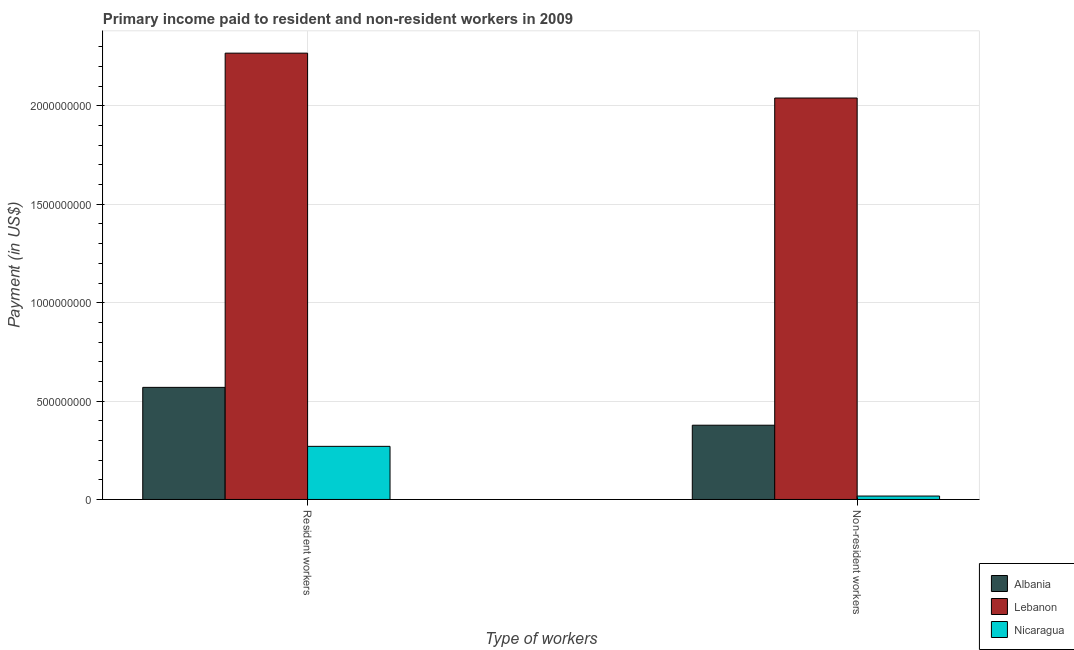How many groups of bars are there?
Give a very brief answer. 2. Are the number of bars on each tick of the X-axis equal?
Your answer should be compact. Yes. How many bars are there on the 2nd tick from the right?
Make the answer very short. 3. What is the label of the 1st group of bars from the left?
Your response must be concise. Resident workers. What is the payment made to resident workers in Albania?
Keep it short and to the point. 5.70e+08. Across all countries, what is the maximum payment made to resident workers?
Your answer should be very brief. 2.27e+09. Across all countries, what is the minimum payment made to resident workers?
Your response must be concise. 2.70e+08. In which country was the payment made to non-resident workers maximum?
Your response must be concise. Lebanon. In which country was the payment made to resident workers minimum?
Offer a very short reply. Nicaragua. What is the total payment made to resident workers in the graph?
Provide a succinct answer. 3.11e+09. What is the difference between the payment made to non-resident workers in Lebanon and that in Nicaragua?
Offer a terse response. 2.02e+09. What is the difference between the payment made to resident workers in Lebanon and the payment made to non-resident workers in Nicaragua?
Provide a short and direct response. 2.25e+09. What is the average payment made to resident workers per country?
Your answer should be very brief. 1.04e+09. What is the difference between the payment made to non-resident workers and payment made to resident workers in Albania?
Offer a very short reply. -1.92e+08. What is the ratio of the payment made to resident workers in Nicaragua to that in Albania?
Ensure brevity in your answer.  0.47. Is the payment made to non-resident workers in Nicaragua less than that in Albania?
Ensure brevity in your answer.  Yes. What does the 1st bar from the left in Non-resident workers represents?
Offer a terse response. Albania. What does the 3rd bar from the right in Non-resident workers represents?
Ensure brevity in your answer.  Albania. How many bars are there?
Offer a very short reply. 6. Are all the bars in the graph horizontal?
Give a very brief answer. No. What is the difference between two consecutive major ticks on the Y-axis?
Offer a terse response. 5.00e+08. Are the values on the major ticks of Y-axis written in scientific E-notation?
Ensure brevity in your answer.  No. Does the graph contain any zero values?
Offer a very short reply. No. How many legend labels are there?
Your answer should be compact. 3. What is the title of the graph?
Provide a succinct answer. Primary income paid to resident and non-resident workers in 2009. Does "Maldives" appear as one of the legend labels in the graph?
Your answer should be compact. No. What is the label or title of the X-axis?
Ensure brevity in your answer.  Type of workers. What is the label or title of the Y-axis?
Your response must be concise. Payment (in US$). What is the Payment (in US$) of Albania in Resident workers?
Provide a short and direct response. 5.70e+08. What is the Payment (in US$) in Lebanon in Resident workers?
Offer a very short reply. 2.27e+09. What is the Payment (in US$) of Nicaragua in Resident workers?
Offer a terse response. 2.70e+08. What is the Payment (in US$) of Albania in Non-resident workers?
Offer a terse response. 3.77e+08. What is the Payment (in US$) of Lebanon in Non-resident workers?
Offer a very short reply. 2.04e+09. What is the Payment (in US$) in Nicaragua in Non-resident workers?
Provide a short and direct response. 1.73e+07. Across all Type of workers, what is the maximum Payment (in US$) in Albania?
Provide a succinct answer. 5.70e+08. Across all Type of workers, what is the maximum Payment (in US$) in Lebanon?
Your answer should be very brief. 2.27e+09. Across all Type of workers, what is the maximum Payment (in US$) in Nicaragua?
Keep it short and to the point. 2.70e+08. Across all Type of workers, what is the minimum Payment (in US$) of Albania?
Offer a terse response. 3.77e+08. Across all Type of workers, what is the minimum Payment (in US$) in Lebanon?
Make the answer very short. 2.04e+09. Across all Type of workers, what is the minimum Payment (in US$) of Nicaragua?
Give a very brief answer. 1.73e+07. What is the total Payment (in US$) of Albania in the graph?
Ensure brevity in your answer.  9.47e+08. What is the total Payment (in US$) of Lebanon in the graph?
Offer a terse response. 4.31e+09. What is the total Payment (in US$) in Nicaragua in the graph?
Offer a very short reply. 2.87e+08. What is the difference between the Payment (in US$) in Albania in Resident workers and that in Non-resident workers?
Make the answer very short. 1.92e+08. What is the difference between the Payment (in US$) of Lebanon in Resident workers and that in Non-resident workers?
Give a very brief answer. 2.28e+08. What is the difference between the Payment (in US$) in Nicaragua in Resident workers and that in Non-resident workers?
Ensure brevity in your answer.  2.53e+08. What is the difference between the Payment (in US$) of Albania in Resident workers and the Payment (in US$) of Lebanon in Non-resident workers?
Provide a short and direct response. -1.47e+09. What is the difference between the Payment (in US$) of Albania in Resident workers and the Payment (in US$) of Nicaragua in Non-resident workers?
Offer a terse response. 5.52e+08. What is the difference between the Payment (in US$) of Lebanon in Resident workers and the Payment (in US$) of Nicaragua in Non-resident workers?
Provide a short and direct response. 2.25e+09. What is the average Payment (in US$) in Albania per Type of workers?
Give a very brief answer. 4.74e+08. What is the average Payment (in US$) of Lebanon per Type of workers?
Provide a short and direct response. 2.15e+09. What is the average Payment (in US$) in Nicaragua per Type of workers?
Keep it short and to the point. 1.44e+08. What is the difference between the Payment (in US$) of Albania and Payment (in US$) of Lebanon in Resident workers?
Give a very brief answer. -1.70e+09. What is the difference between the Payment (in US$) in Albania and Payment (in US$) in Nicaragua in Resident workers?
Provide a short and direct response. 3.00e+08. What is the difference between the Payment (in US$) in Lebanon and Payment (in US$) in Nicaragua in Resident workers?
Your answer should be very brief. 2.00e+09. What is the difference between the Payment (in US$) in Albania and Payment (in US$) in Lebanon in Non-resident workers?
Your answer should be compact. -1.66e+09. What is the difference between the Payment (in US$) in Albania and Payment (in US$) in Nicaragua in Non-resident workers?
Keep it short and to the point. 3.60e+08. What is the difference between the Payment (in US$) of Lebanon and Payment (in US$) of Nicaragua in Non-resident workers?
Your response must be concise. 2.02e+09. What is the ratio of the Payment (in US$) of Albania in Resident workers to that in Non-resident workers?
Provide a succinct answer. 1.51. What is the ratio of the Payment (in US$) of Lebanon in Resident workers to that in Non-resident workers?
Offer a terse response. 1.11. What is the ratio of the Payment (in US$) of Nicaragua in Resident workers to that in Non-resident workers?
Keep it short and to the point. 15.6. What is the difference between the highest and the second highest Payment (in US$) of Albania?
Give a very brief answer. 1.92e+08. What is the difference between the highest and the second highest Payment (in US$) in Lebanon?
Offer a terse response. 2.28e+08. What is the difference between the highest and the second highest Payment (in US$) in Nicaragua?
Ensure brevity in your answer.  2.53e+08. What is the difference between the highest and the lowest Payment (in US$) in Albania?
Offer a terse response. 1.92e+08. What is the difference between the highest and the lowest Payment (in US$) of Lebanon?
Ensure brevity in your answer.  2.28e+08. What is the difference between the highest and the lowest Payment (in US$) of Nicaragua?
Offer a terse response. 2.53e+08. 